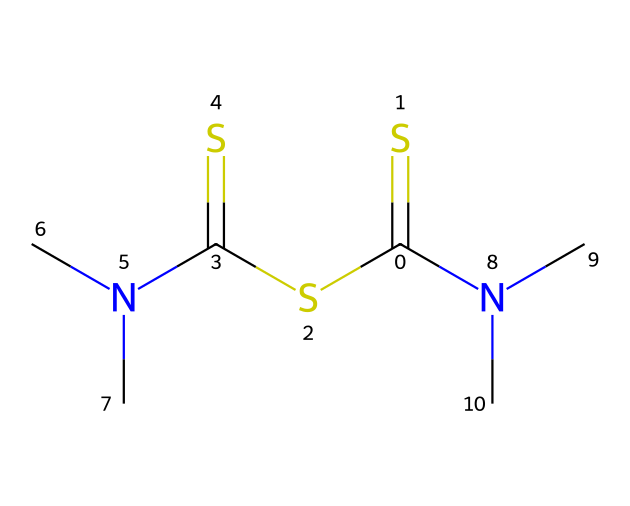How many sulfur atoms are present in thiram? In the given SMILES representation, there are two occurrences of the 'S' character, indicating that there are two sulfur atoms present in the molecule.
Answer: 2 What functional groups can be identified in thiram? Upon analyzing the structure, we can see that thiram contains thioamide (from the 'C(=S)' part) and secondary amine (from 'N(C)C') functional groups. Both are characteristic functional groups in this compound.
Answer: thioamide, secondary amine What is the total number of nitrogen atoms in thiram? The SMILES notation shows two 'N' characters, which indicates that there are two nitrogen atoms present in the molecular structure of thiram.
Answer: 2 Based on its composition, does thiram contain any rings in its structure? Examining the SMILES representation, we see that there are no cyclic structures or ring formations present; all atoms are linked in a linear fashion.
Answer: no What is the likely role of thiram in agriculture? Thiram is known for its use as a fungicide, primarily preventing and controlling fungal diseases in crops, which is reflected in its chemical structure that allows for activity against fungal pathogens.
Answer: fungicide How many carbon atoms are found in thiram? By counting the 'C' characters in the SMILES string, we determine that there are five carbon atoms in total represented in the molecule.
Answer: 5 